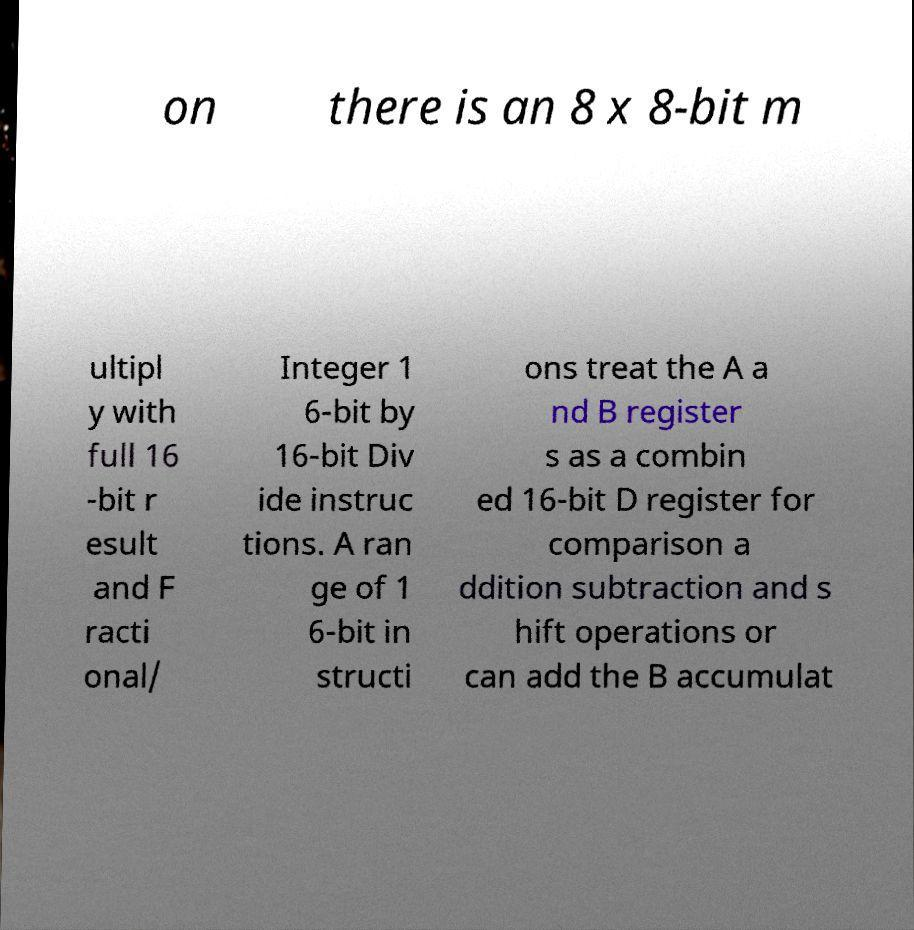Please read and relay the text visible in this image. What does it say? on there is an 8 x 8-bit m ultipl y with full 16 -bit r esult and F racti onal/ Integer 1 6-bit by 16-bit Div ide instruc tions. A ran ge of 1 6-bit in structi ons treat the A a nd B register s as a combin ed 16-bit D register for comparison a ddition subtraction and s hift operations or can add the B accumulat 